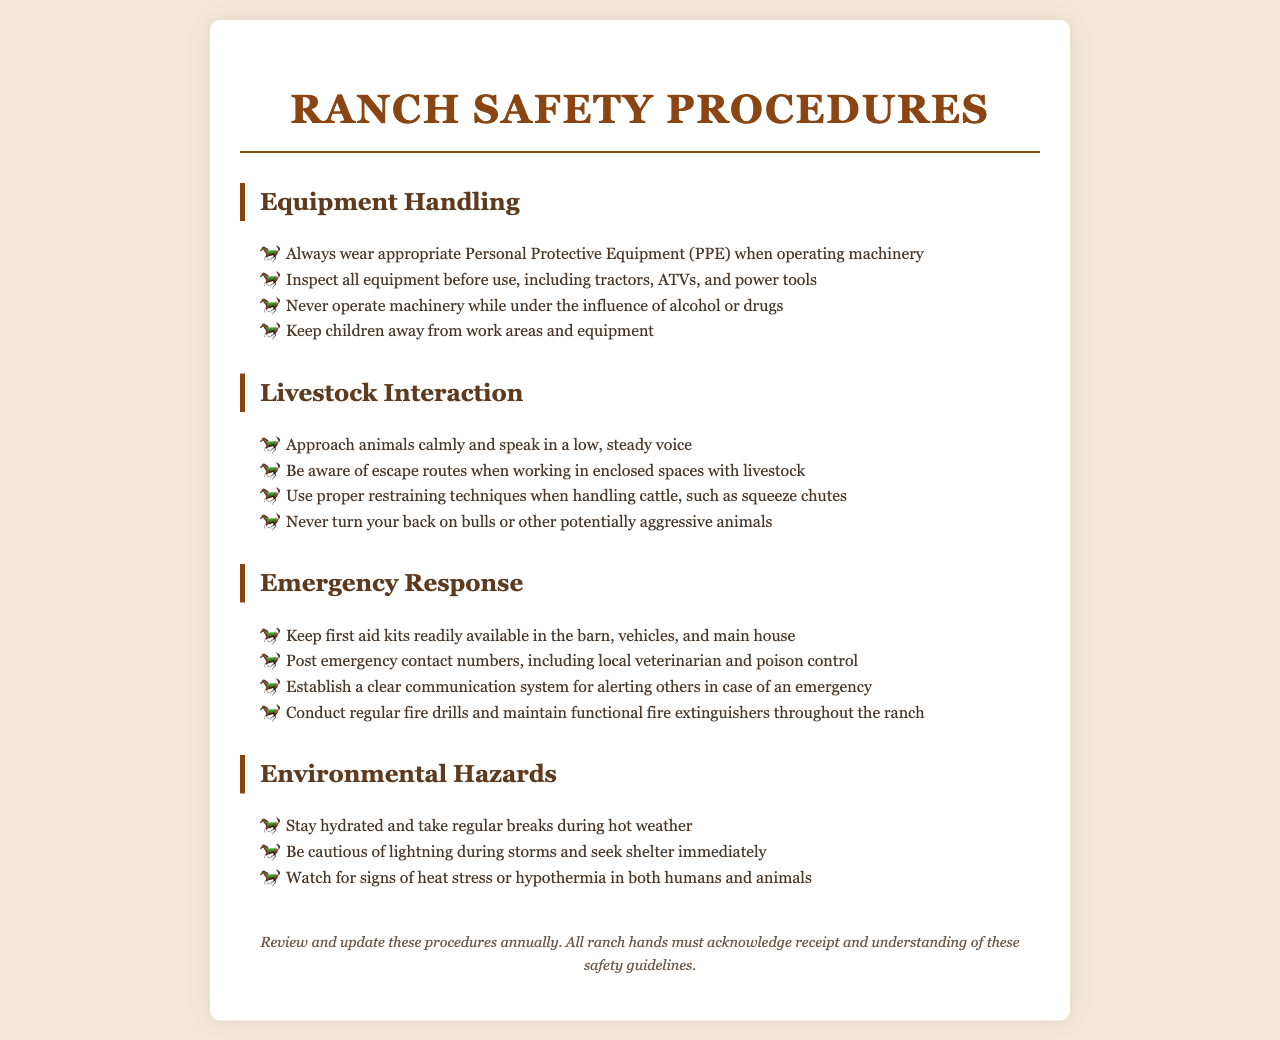What should be worn when operating machinery? The document states that appropriate Personal Protective Equipment (PPE) should be worn when operating machinery.
Answer: Personal Protective Equipment (PPE) What is one key technique for handling cattle? The document mentions that proper restraining techniques, such as squeeze chutes, should be used when handling cattle.
Answer: Squeeze chutes What should be kept readily available in the barn? The document specifies that first aid kits should be readily available in the barn, vehicles, and main house.
Answer: First aid kits What should be done during hot weather? The document advises staying hydrated and taking regular breaks during hot weather.
Answer: Stay hydrated What should be established for alerting others in an emergency? The document states that a clear communication system should be established for alerting others in case of an emergency.
Answer: Clear communication system How often should procedures be reviewed and updated? According to the document, procedures should be reviewed and updated annually.
Answer: Annually What should be posted for emergencies? The document indicates that emergency contact numbers should be posted, including local veterinarian and poison control.
Answer: Emergency contact numbers What animal behavior should be avoided? The document warns to never turn your back on bulls or other potentially aggressive animals.
Answer: Never turn your back What is the warning related to lightning during storms? The document advises to seek shelter immediately during storms when there are signs of lightning.
Answer: Seek shelter immediately 